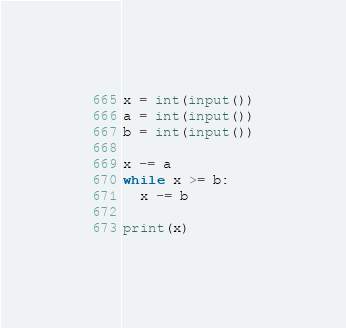<code> <loc_0><loc_0><loc_500><loc_500><_Python_>x = int(input())
a = int(input())
b = int(input())

x -= a
while x >= b:
  x -= b
  
print(x)</code> 